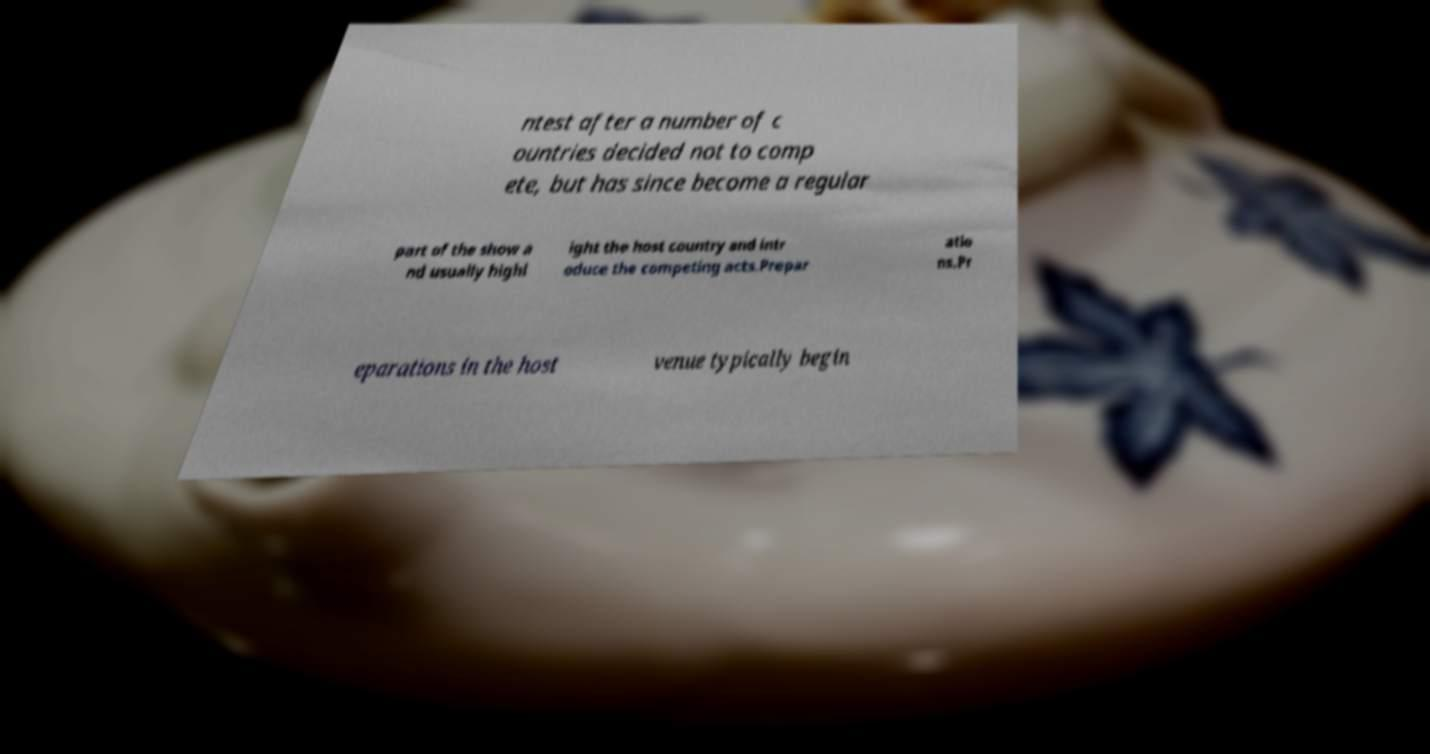Could you extract and type out the text from this image? ntest after a number of c ountries decided not to comp ete, but has since become a regular part of the show a nd usually highl ight the host country and intr oduce the competing acts.Prepar atio ns.Pr eparations in the host venue typically begin 